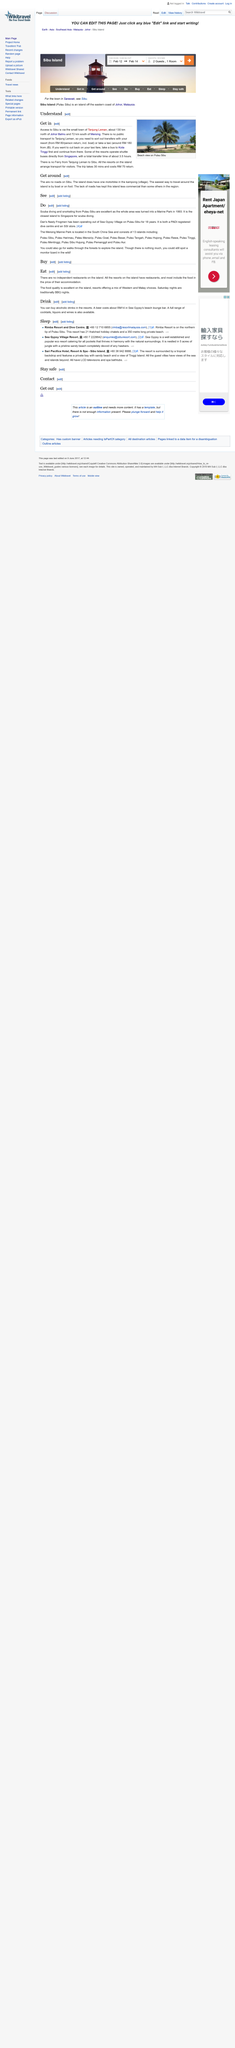Identify some key points in this picture. The above picture was taken at Pulau Sibu. The transfer time from Singapore is approximately 3.5 hours. Sibu, a town in Malaysia, can only be accessed through the small town of Tanjung Leman. 